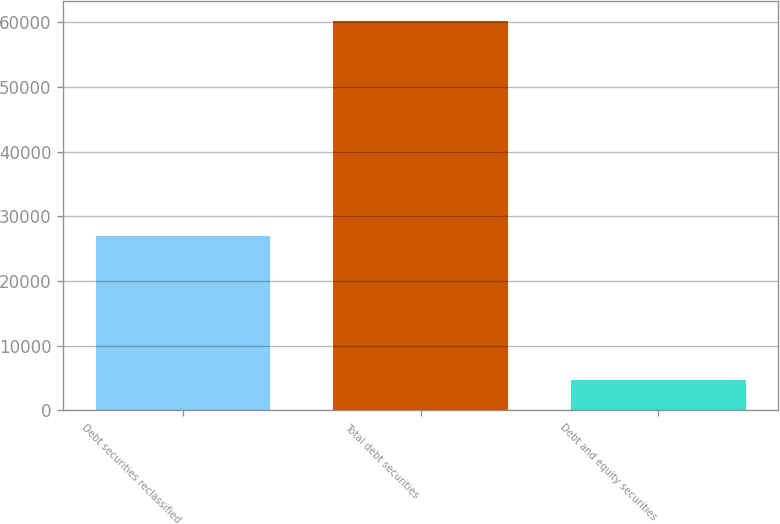Convert chart. <chart><loc_0><loc_0><loc_500><loc_500><bar_chart><fcel>Debt securities reclassified<fcel>Total debt securities<fcel>Debt and equity securities<nl><fcel>27005<fcel>60263<fcel>4654<nl></chart> 